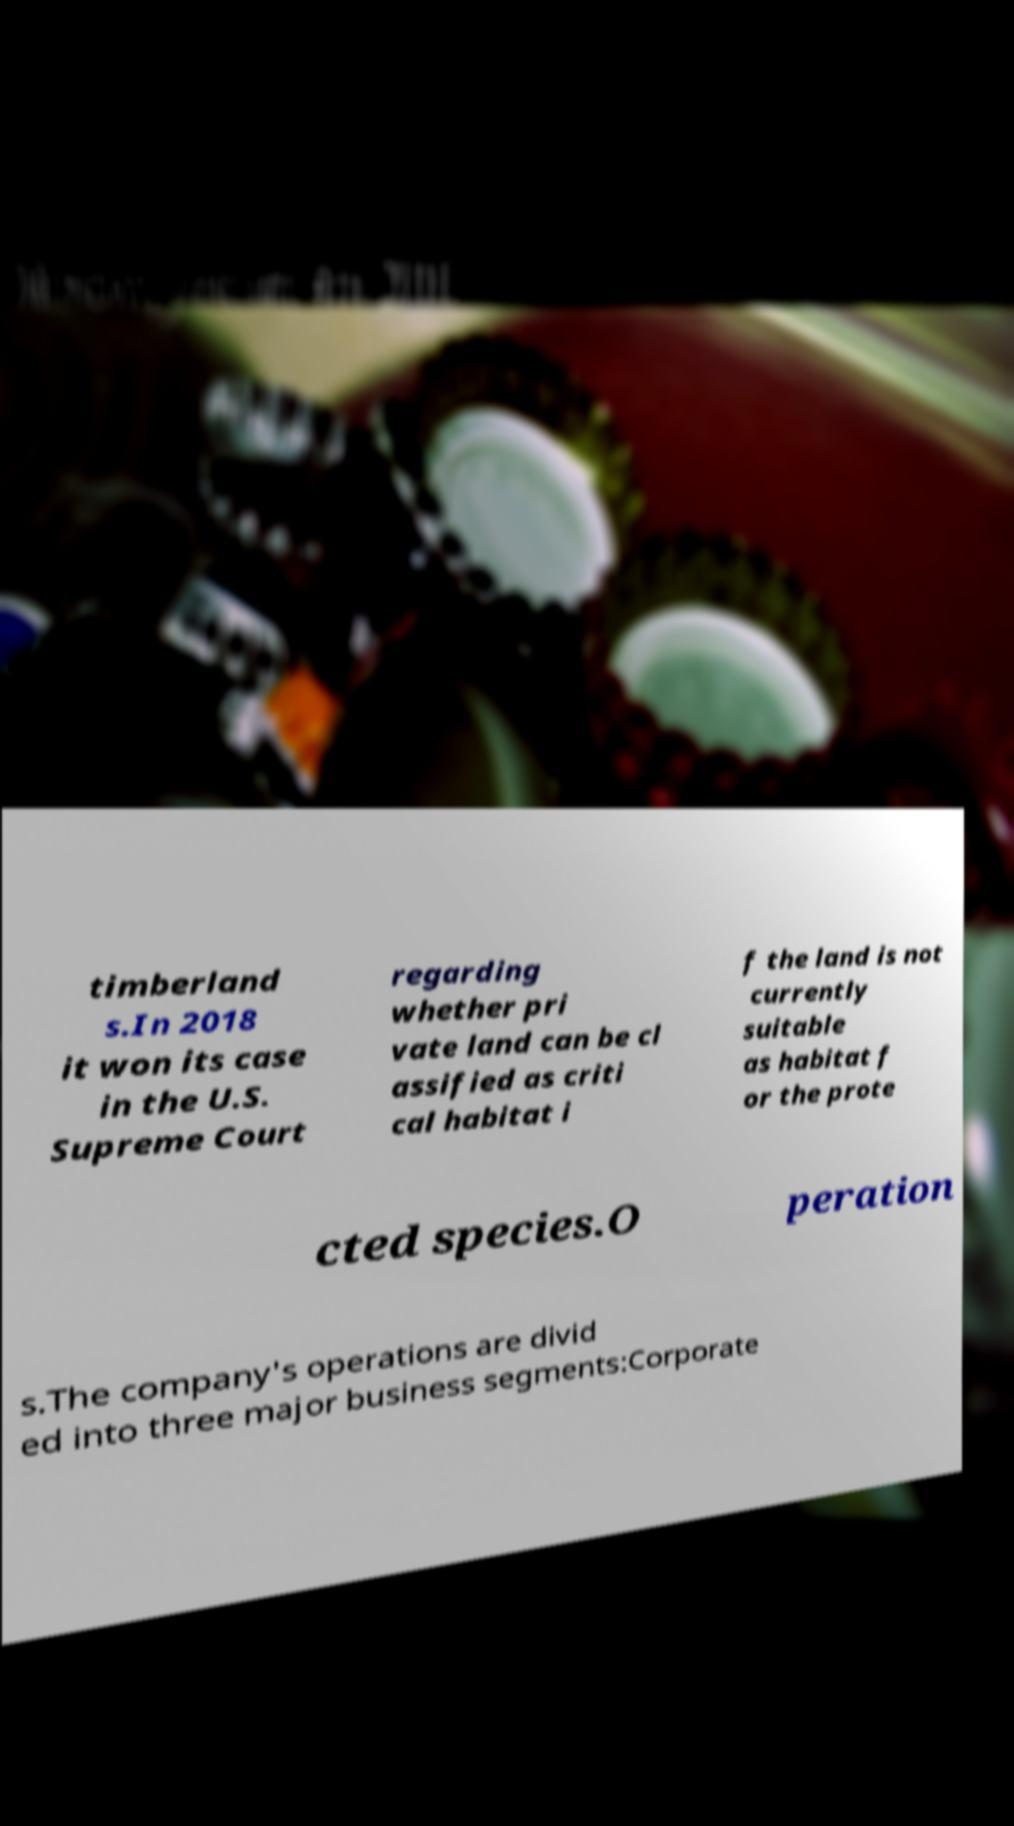What messages or text are displayed in this image? I need them in a readable, typed format. timberland s.In 2018 it won its case in the U.S. Supreme Court regarding whether pri vate land can be cl assified as criti cal habitat i f the land is not currently suitable as habitat f or the prote cted species.O peration s.The company's operations are divid ed into three major business segments:Corporate 